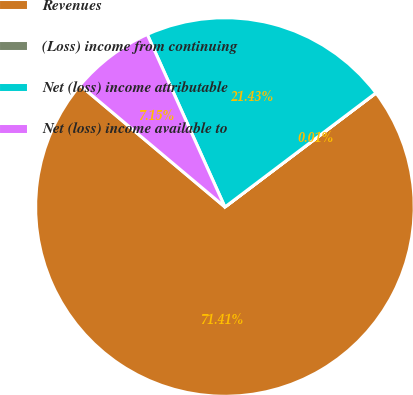Convert chart to OTSL. <chart><loc_0><loc_0><loc_500><loc_500><pie_chart><fcel>Revenues<fcel>(Loss) income from continuing<fcel>Net (loss) income attributable<fcel>Net (loss) income available to<nl><fcel>71.41%<fcel>0.01%<fcel>21.43%<fcel>7.15%<nl></chart> 